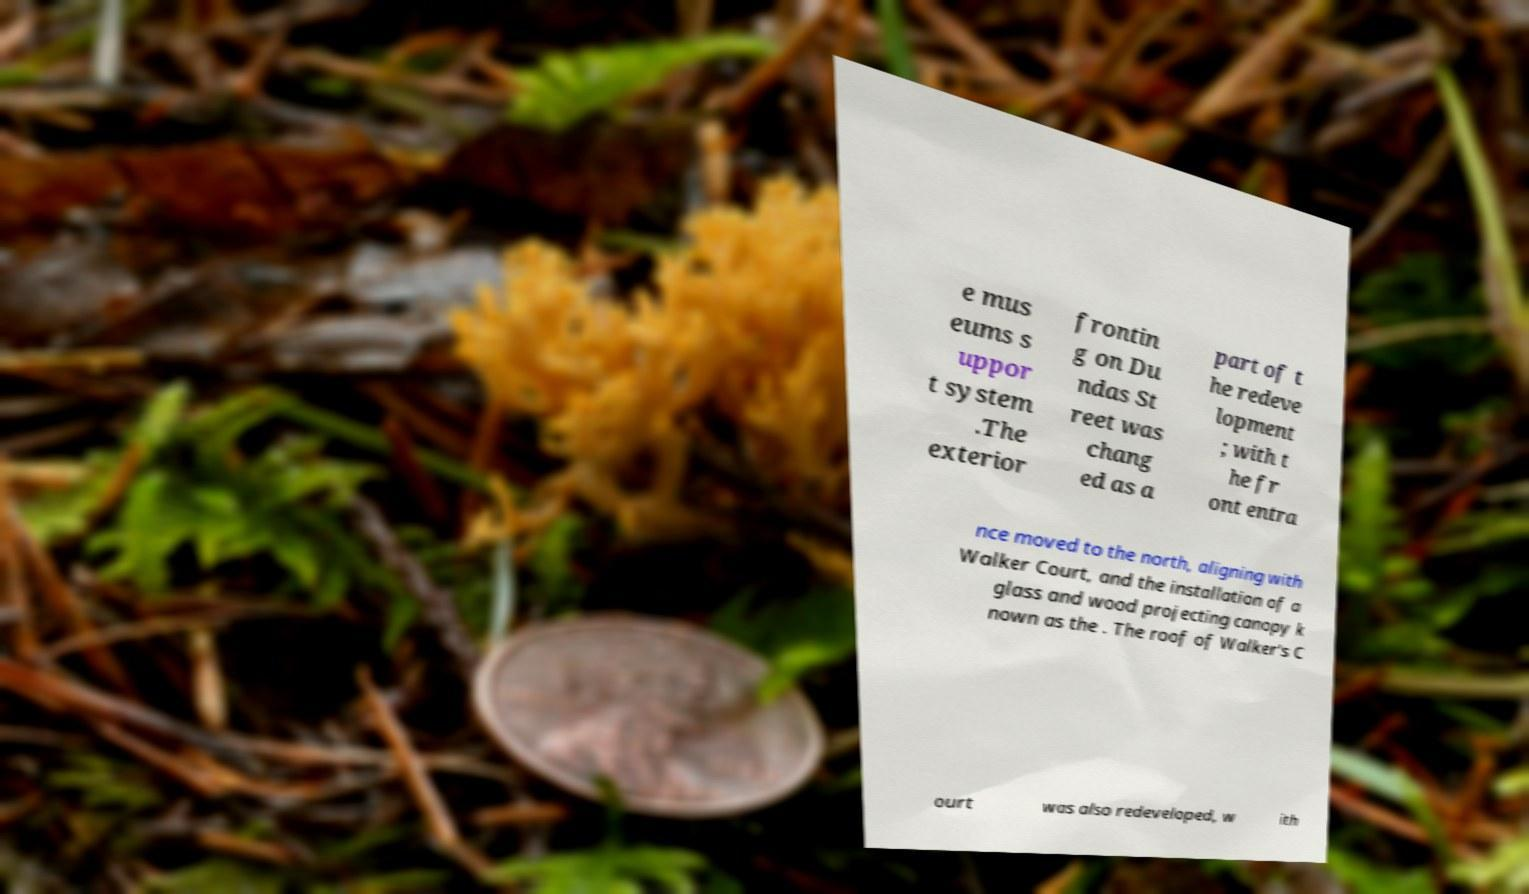Could you extract and type out the text from this image? e mus eums s uppor t system .The exterior frontin g on Du ndas St reet was chang ed as a part of t he redeve lopment ; with t he fr ont entra nce moved to the north, aligning with Walker Court, and the installation of a glass and wood projecting canopy k nown as the . The roof of Walker's C ourt was also redeveloped, w ith 